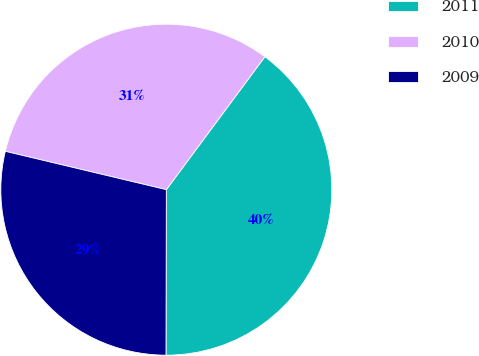<chart> <loc_0><loc_0><loc_500><loc_500><pie_chart><fcel>2011<fcel>2010<fcel>2009<nl><fcel>39.88%<fcel>31.43%<fcel>28.69%<nl></chart> 